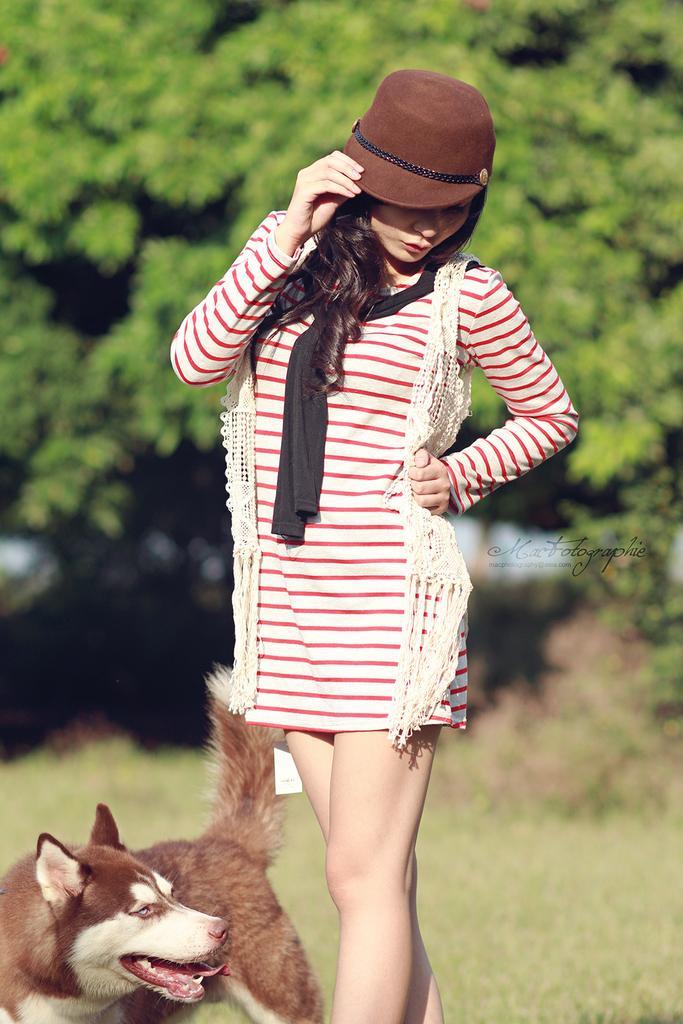Describe this image in one or two sentences. In this image in the center there is one woman who is standing, and she is wearing a cap beside her there is one dog. At the bottom there is grass and in the background there are trees, and in the center of the image there is text. 